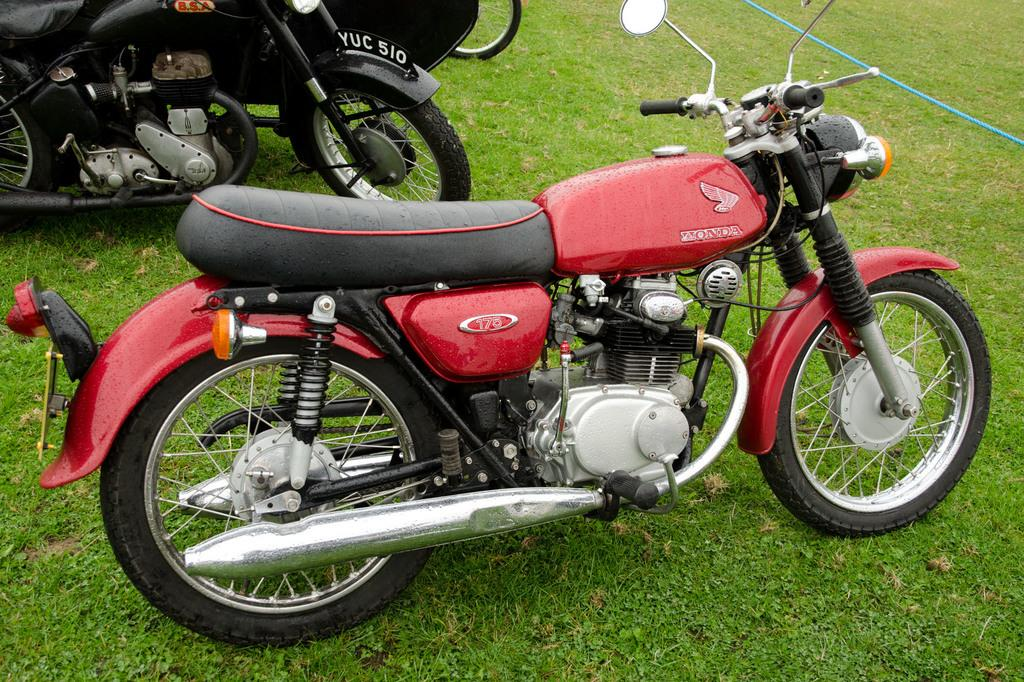What type of vehicles are in the image? There are motorcycles in the image. Where are the motorcycles located? The motorcycles are on the ground. What can be seen in the background of the image? There is grass visible in the background of the image. What type of scarecrow is standing next to the motorcycles in the image? There is no scarecrow present in the image. How many copies of the motorcycles can be seen in the image? There is only one set of motorcycles visible in the image, so there are no copies. 